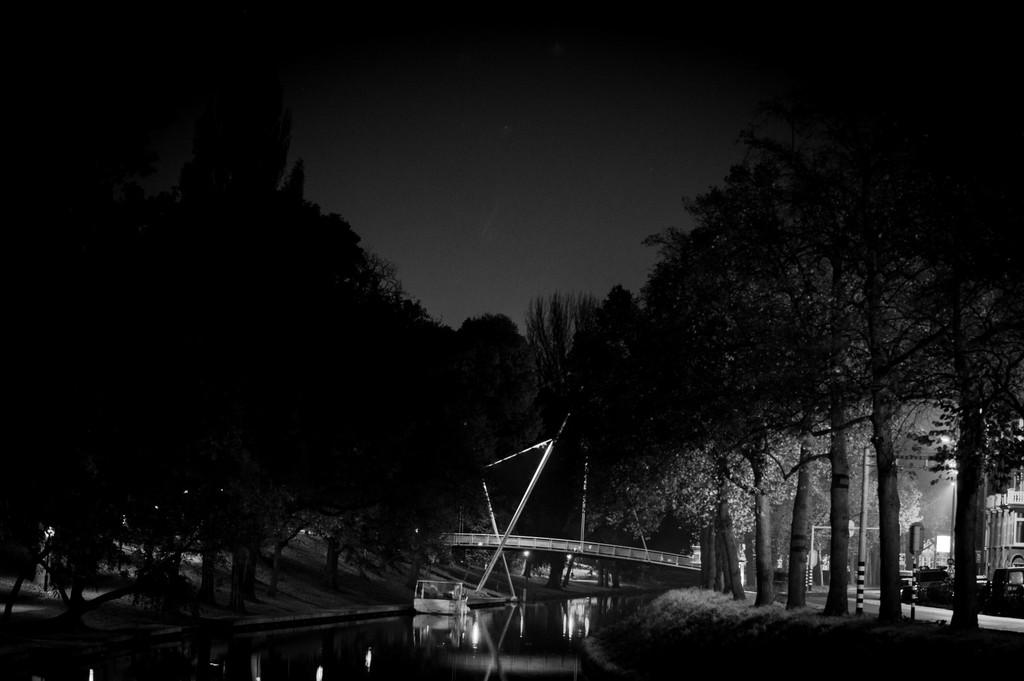What is the main subject of the image? The main subject of the image is a boat on the water. What other structures or objects can be seen in the image? There is a bridge, vehicles, poles, a building, and trees visible in the image. What is the background of the image? The sky is visible in the background of the image. What time of day is it in the image, based on the hour hand of the clock? There is no clock present in the image, so it is not possible to determine the time of day based on an hour hand. 